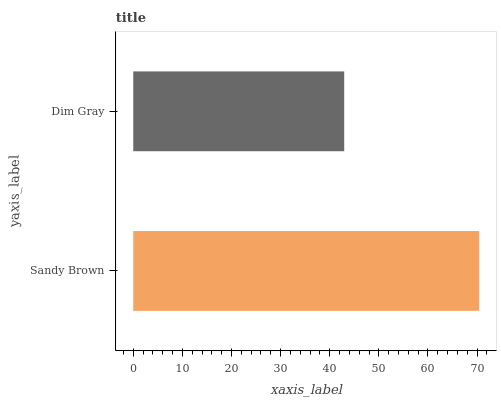Is Dim Gray the minimum?
Answer yes or no. Yes. Is Sandy Brown the maximum?
Answer yes or no. Yes. Is Dim Gray the maximum?
Answer yes or no. No. Is Sandy Brown greater than Dim Gray?
Answer yes or no. Yes. Is Dim Gray less than Sandy Brown?
Answer yes or no. Yes. Is Dim Gray greater than Sandy Brown?
Answer yes or no. No. Is Sandy Brown less than Dim Gray?
Answer yes or no. No. Is Sandy Brown the high median?
Answer yes or no. Yes. Is Dim Gray the low median?
Answer yes or no. Yes. Is Dim Gray the high median?
Answer yes or no. No. Is Sandy Brown the low median?
Answer yes or no. No. 